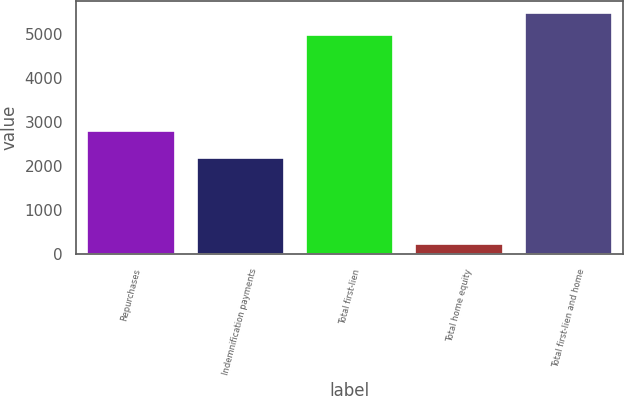Convert chart. <chart><loc_0><loc_0><loc_500><loc_500><bar_chart><fcel>Repurchases<fcel>Indemnification payments<fcel>Total first-lien<fcel>Total home equity<fcel>Total first-lien and home<nl><fcel>2799<fcel>2173<fcel>4972<fcel>232<fcel>5469.2<nl></chart> 